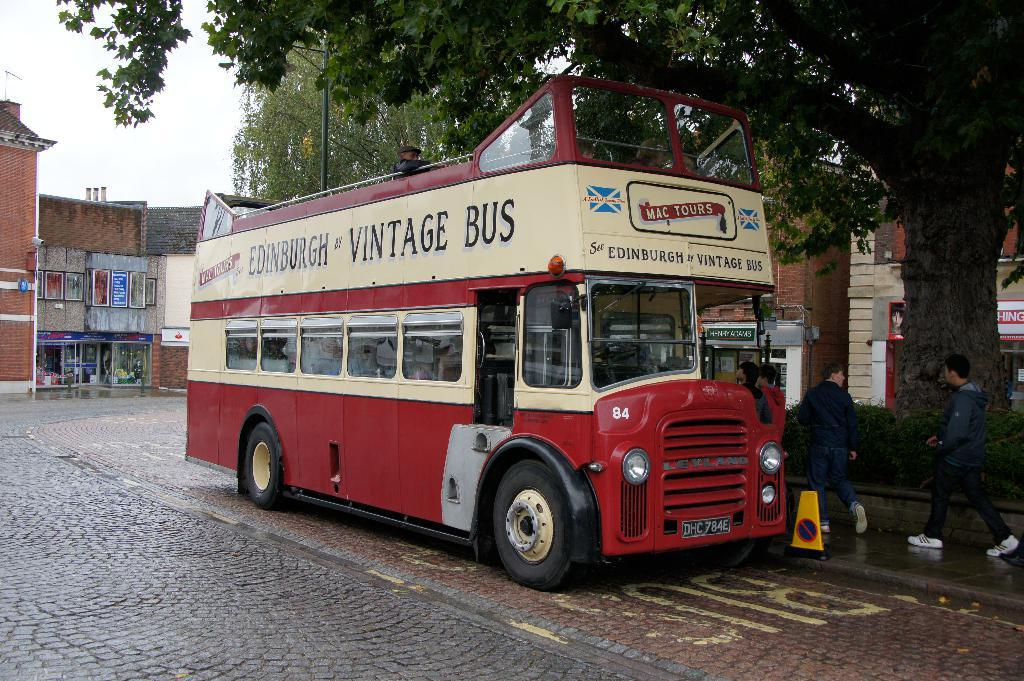<image>
Share a concise interpretation of the image provided. A vintage bus in the UK with passengers in line to get on it. 